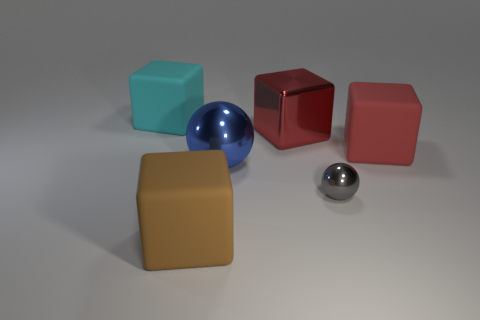Subtract 1 cubes. How many cubes are left? 3 Add 1 big blue objects. How many objects exist? 7 Subtract all cubes. How many objects are left? 2 Subtract 1 gray spheres. How many objects are left? 5 Subtract all large spheres. Subtract all big red blocks. How many objects are left? 3 Add 5 brown things. How many brown things are left? 6 Add 2 gray metallic objects. How many gray metallic objects exist? 3 